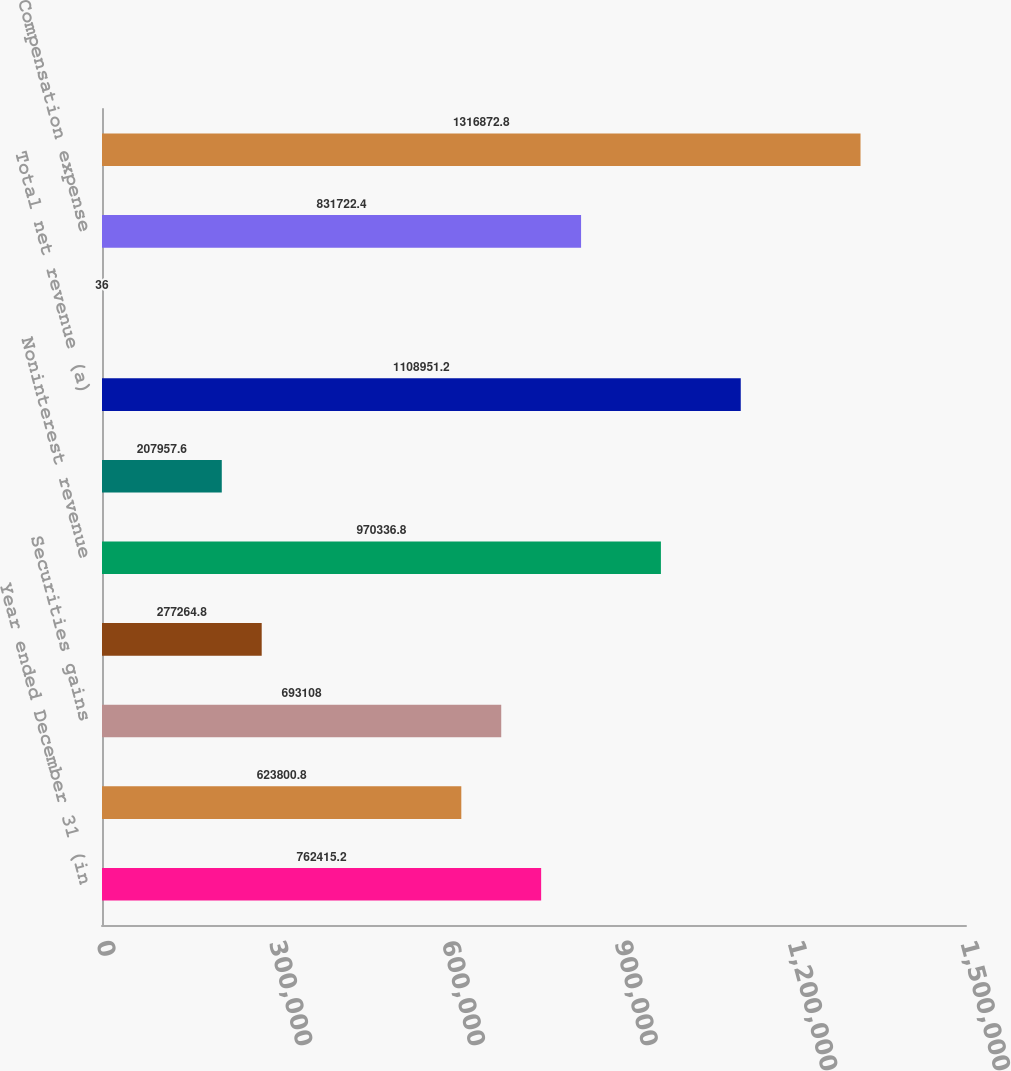Convert chart. <chart><loc_0><loc_0><loc_500><loc_500><bar_chart><fcel>Year ended December 31 (in<fcel>Principal transactions<fcel>Securities gains<fcel>All other income<fcel>Noninterest revenue<fcel>Net interest income<fcel>Total net revenue (a)<fcel>Provision for credit losses<fcel>Compensation expense<fcel>Noncompensation expense (b)<nl><fcel>762415<fcel>623801<fcel>693108<fcel>277265<fcel>970337<fcel>207958<fcel>1.10895e+06<fcel>36<fcel>831722<fcel>1.31687e+06<nl></chart> 